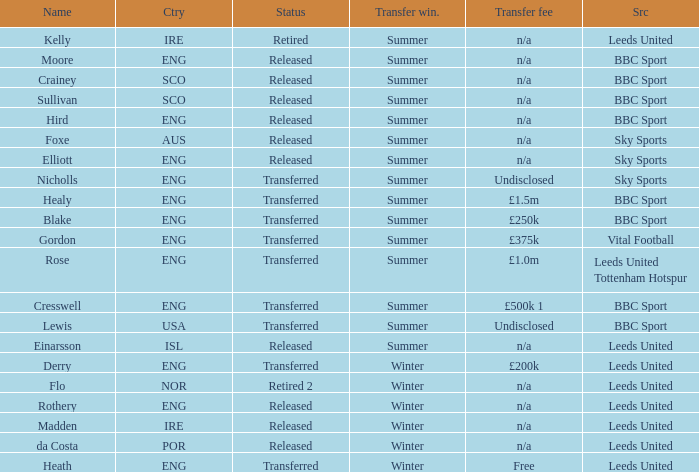What was the source for the person named Cresswell? BBC Sport. 